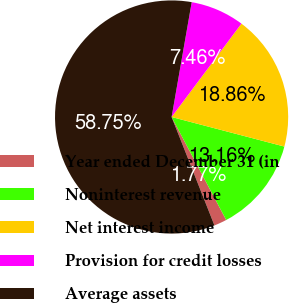Convert chart to OTSL. <chart><loc_0><loc_0><loc_500><loc_500><pie_chart><fcel>Year ended December 31 (in<fcel>Noninterest revenue<fcel>Net interest income<fcel>Provision for credit losses<fcel>Average assets<nl><fcel>1.77%<fcel>13.16%<fcel>18.86%<fcel>7.46%<fcel>58.75%<nl></chart> 